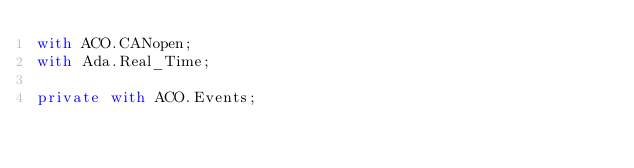<code> <loc_0><loc_0><loc_500><loc_500><_Ada_>with ACO.CANopen;
with Ada.Real_Time;

private with ACO.Events;
</code> 